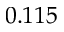Convert formula to latex. <formula><loc_0><loc_0><loc_500><loc_500>0 . 1 1 5</formula> 